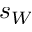Convert formula to latex. <formula><loc_0><loc_0><loc_500><loc_500>s _ { W }</formula> 